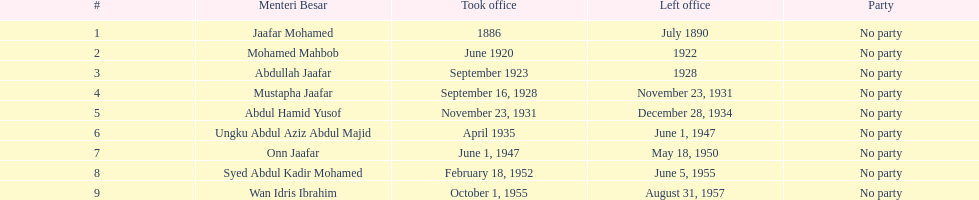Name someone who was not in office more than 4 years. Mohamed Mahbob. I'm looking to parse the entire table for insights. Could you assist me with that? {'header': ['#', 'Menteri Besar', 'Took office', 'Left office', 'Party'], 'rows': [['1', 'Jaafar Mohamed', '1886', 'July 1890', 'No party'], ['2', 'Mohamed Mahbob', 'June 1920', '1922', 'No party'], ['3', 'Abdullah Jaafar', 'September 1923', '1928', 'No party'], ['4', 'Mustapha Jaafar', 'September 16, 1928', 'November 23, 1931', 'No party'], ['5', 'Abdul Hamid Yusof', 'November 23, 1931', 'December 28, 1934', 'No party'], ['6', 'Ungku Abdul Aziz Abdul Majid', 'April 1935', 'June 1, 1947', 'No party'], ['7', 'Onn Jaafar', 'June 1, 1947', 'May 18, 1950', 'No party'], ['8', 'Syed Abdul Kadir Mohamed', 'February 18, 1952', 'June 5, 1955', 'No party'], ['9', 'Wan Idris Ibrahim', 'October 1, 1955', 'August 31, 1957', 'No party']]} 